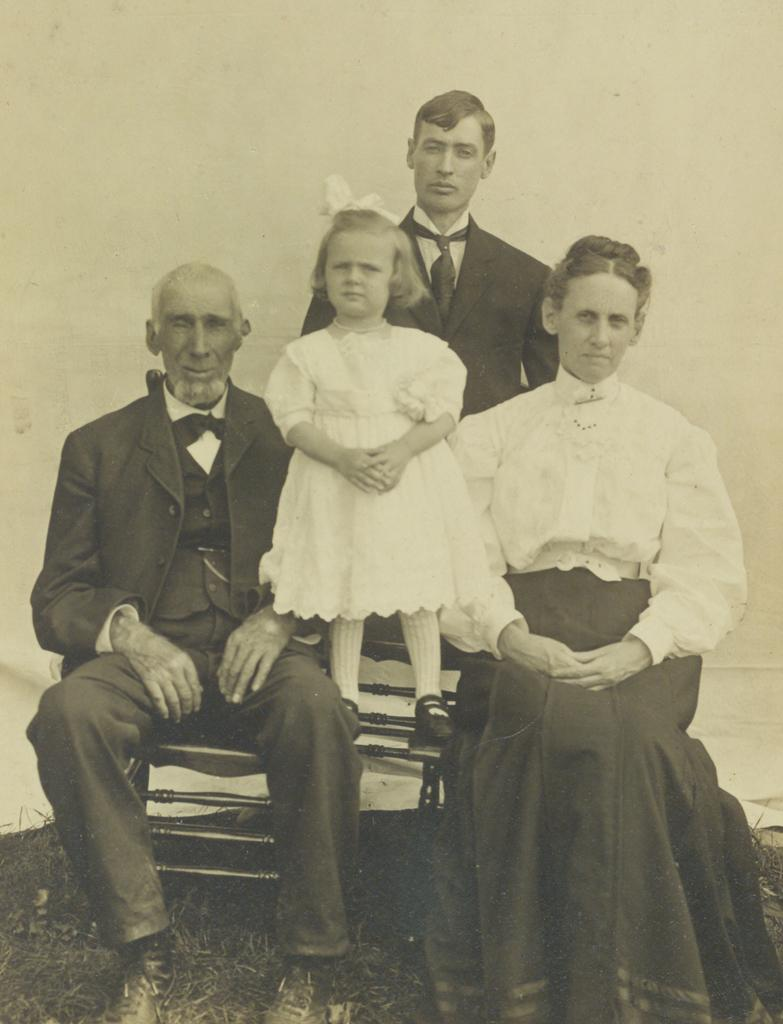Who are the people sitting on the bench in the image? There is a man and a woman sitting on a bench in the image. What is happening with the baby in the image? There is a baby standing between the man and the woman. Can you describe the position of the other man in the image? There is another man standing on the grass behind the first three people. What day of the week is it in the image? The day of the week is not mentioned or visible in the image. What type of government is depicted in the image? There is no reference to any government or political system in the image. 